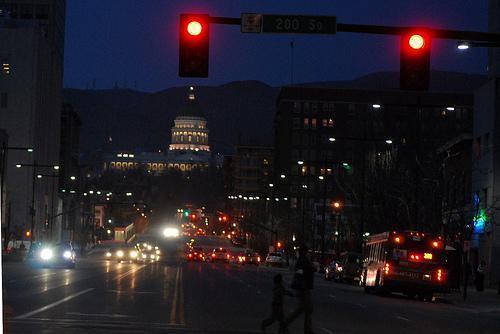How many people are crossing the street?
Give a very brief answer. 2. 